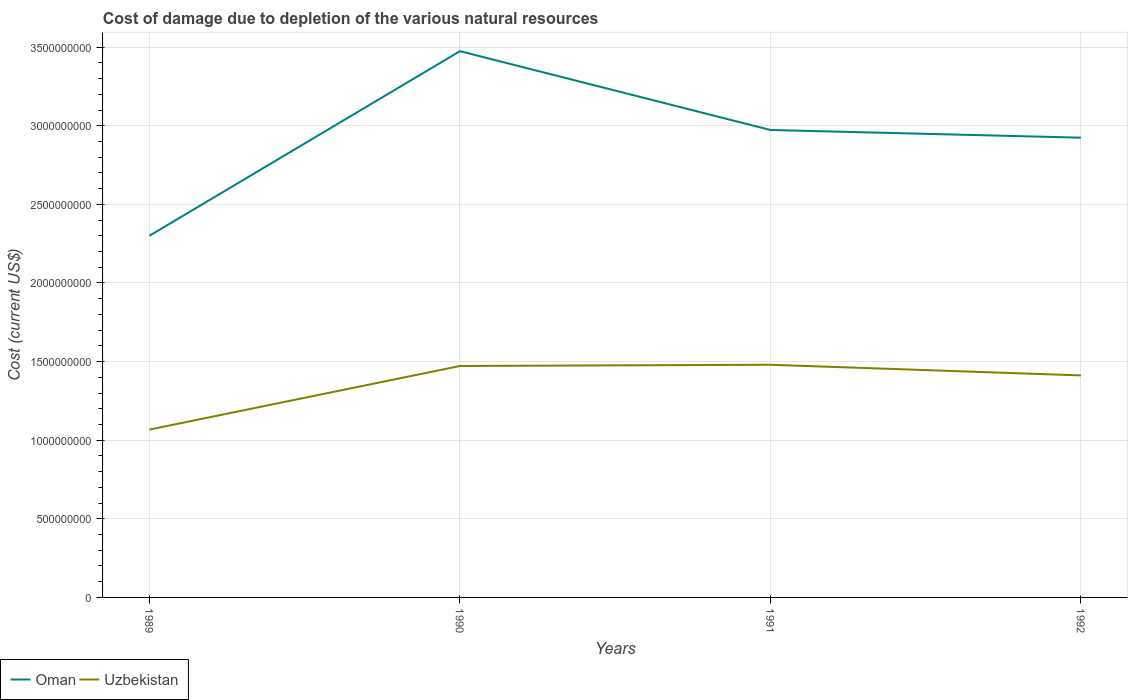Does the line corresponding to Uzbekistan intersect with the line corresponding to Oman?
Offer a very short reply. No. Across all years, what is the maximum cost of damage caused due to the depletion of various natural resources in Uzbekistan?
Provide a short and direct response. 1.07e+09. What is the total cost of damage caused due to the depletion of various natural resources in Uzbekistan in the graph?
Offer a terse response. -4.04e+08. What is the difference between the highest and the second highest cost of damage caused due to the depletion of various natural resources in Oman?
Ensure brevity in your answer.  1.17e+09. Does the graph contain grids?
Provide a succinct answer. Yes. Where does the legend appear in the graph?
Your answer should be very brief. Bottom left. What is the title of the graph?
Offer a very short reply. Cost of damage due to depletion of the various natural resources. Does "Serbia" appear as one of the legend labels in the graph?
Your answer should be very brief. No. What is the label or title of the X-axis?
Offer a terse response. Years. What is the label or title of the Y-axis?
Provide a succinct answer. Cost (current US$). What is the Cost (current US$) in Oman in 1989?
Make the answer very short. 2.30e+09. What is the Cost (current US$) of Uzbekistan in 1989?
Provide a succinct answer. 1.07e+09. What is the Cost (current US$) in Oman in 1990?
Give a very brief answer. 3.47e+09. What is the Cost (current US$) in Uzbekistan in 1990?
Provide a succinct answer. 1.47e+09. What is the Cost (current US$) of Oman in 1991?
Offer a very short reply. 2.97e+09. What is the Cost (current US$) of Uzbekistan in 1991?
Your answer should be very brief. 1.48e+09. What is the Cost (current US$) in Oman in 1992?
Give a very brief answer. 2.92e+09. What is the Cost (current US$) of Uzbekistan in 1992?
Offer a terse response. 1.41e+09. Across all years, what is the maximum Cost (current US$) of Oman?
Make the answer very short. 3.47e+09. Across all years, what is the maximum Cost (current US$) of Uzbekistan?
Ensure brevity in your answer.  1.48e+09. Across all years, what is the minimum Cost (current US$) in Oman?
Provide a succinct answer. 2.30e+09. Across all years, what is the minimum Cost (current US$) in Uzbekistan?
Provide a short and direct response. 1.07e+09. What is the total Cost (current US$) in Oman in the graph?
Your answer should be compact. 1.17e+1. What is the total Cost (current US$) in Uzbekistan in the graph?
Offer a very short reply. 5.43e+09. What is the difference between the Cost (current US$) of Oman in 1989 and that in 1990?
Your answer should be compact. -1.17e+09. What is the difference between the Cost (current US$) in Uzbekistan in 1989 and that in 1990?
Keep it short and to the point. -4.04e+08. What is the difference between the Cost (current US$) of Oman in 1989 and that in 1991?
Your response must be concise. -6.73e+08. What is the difference between the Cost (current US$) in Uzbekistan in 1989 and that in 1991?
Give a very brief answer. -4.12e+08. What is the difference between the Cost (current US$) in Oman in 1989 and that in 1992?
Your answer should be very brief. -6.24e+08. What is the difference between the Cost (current US$) of Uzbekistan in 1989 and that in 1992?
Your answer should be compact. -3.44e+08. What is the difference between the Cost (current US$) in Oman in 1990 and that in 1991?
Make the answer very short. 5.01e+08. What is the difference between the Cost (current US$) in Uzbekistan in 1990 and that in 1991?
Offer a terse response. -7.81e+06. What is the difference between the Cost (current US$) of Oman in 1990 and that in 1992?
Offer a terse response. 5.50e+08. What is the difference between the Cost (current US$) in Uzbekistan in 1990 and that in 1992?
Provide a succinct answer. 6.00e+07. What is the difference between the Cost (current US$) of Oman in 1991 and that in 1992?
Ensure brevity in your answer.  4.89e+07. What is the difference between the Cost (current US$) in Uzbekistan in 1991 and that in 1992?
Offer a very short reply. 6.78e+07. What is the difference between the Cost (current US$) of Oman in 1989 and the Cost (current US$) of Uzbekistan in 1990?
Ensure brevity in your answer.  8.28e+08. What is the difference between the Cost (current US$) of Oman in 1989 and the Cost (current US$) of Uzbekistan in 1991?
Give a very brief answer. 8.21e+08. What is the difference between the Cost (current US$) in Oman in 1989 and the Cost (current US$) in Uzbekistan in 1992?
Ensure brevity in your answer.  8.88e+08. What is the difference between the Cost (current US$) in Oman in 1990 and the Cost (current US$) in Uzbekistan in 1991?
Offer a terse response. 1.99e+09. What is the difference between the Cost (current US$) in Oman in 1990 and the Cost (current US$) in Uzbekistan in 1992?
Offer a terse response. 2.06e+09. What is the difference between the Cost (current US$) of Oman in 1991 and the Cost (current US$) of Uzbekistan in 1992?
Provide a succinct answer. 1.56e+09. What is the average Cost (current US$) of Oman per year?
Your response must be concise. 2.92e+09. What is the average Cost (current US$) of Uzbekistan per year?
Provide a succinct answer. 1.36e+09. In the year 1989, what is the difference between the Cost (current US$) of Oman and Cost (current US$) of Uzbekistan?
Your response must be concise. 1.23e+09. In the year 1990, what is the difference between the Cost (current US$) in Oman and Cost (current US$) in Uzbekistan?
Keep it short and to the point. 2.00e+09. In the year 1991, what is the difference between the Cost (current US$) in Oman and Cost (current US$) in Uzbekistan?
Provide a short and direct response. 1.49e+09. In the year 1992, what is the difference between the Cost (current US$) in Oman and Cost (current US$) in Uzbekistan?
Keep it short and to the point. 1.51e+09. What is the ratio of the Cost (current US$) in Oman in 1989 to that in 1990?
Provide a succinct answer. 0.66. What is the ratio of the Cost (current US$) of Uzbekistan in 1989 to that in 1990?
Provide a short and direct response. 0.73. What is the ratio of the Cost (current US$) in Oman in 1989 to that in 1991?
Ensure brevity in your answer.  0.77. What is the ratio of the Cost (current US$) in Uzbekistan in 1989 to that in 1991?
Ensure brevity in your answer.  0.72. What is the ratio of the Cost (current US$) in Oman in 1989 to that in 1992?
Ensure brevity in your answer.  0.79. What is the ratio of the Cost (current US$) in Uzbekistan in 1989 to that in 1992?
Your answer should be compact. 0.76. What is the ratio of the Cost (current US$) of Oman in 1990 to that in 1991?
Provide a succinct answer. 1.17. What is the ratio of the Cost (current US$) in Oman in 1990 to that in 1992?
Your answer should be compact. 1.19. What is the ratio of the Cost (current US$) in Uzbekistan in 1990 to that in 1992?
Your answer should be very brief. 1.04. What is the ratio of the Cost (current US$) of Oman in 1991 to that in 1992?
Your answer should be compact. 1.02. What is the ratio of the Cost (current US$) of Uzbekistan in 1991 to that in 1992?
Your answer should be compact. 1.05. What is the difference between the highest and the second highest Cost (current US$) of Oman?
Your response must be concise. 5.01e+08. What is the difference between the highest and the second highest Cost (current US$) of Uzbekistan?
Your response must be concise. 7.81e+06. What is the difference between the highest and the lowest Cost (current US$) of Oman?
Your answer should be very brief. 1.17e+09. What is the difference between the highest and the lowest Cost (current US$) in Uzbekistan?
Make the answer very short. 4.12e+08. 